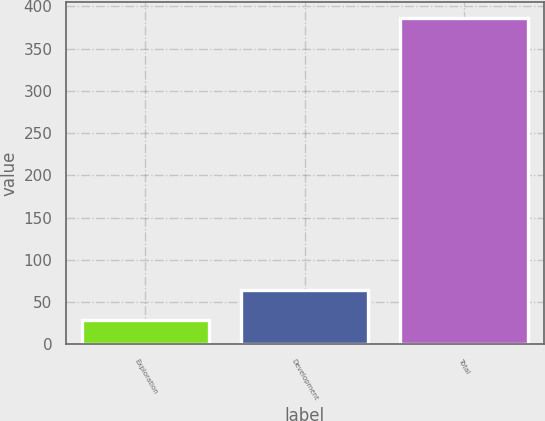<chart> <loc_0><loc_0><loc_500><loc_500><bar_chart><fcel>Exploration<fcel>Development<fcel>Total<nl><fcel>29<fcel>64.7<fcel>386<nl></chart> 